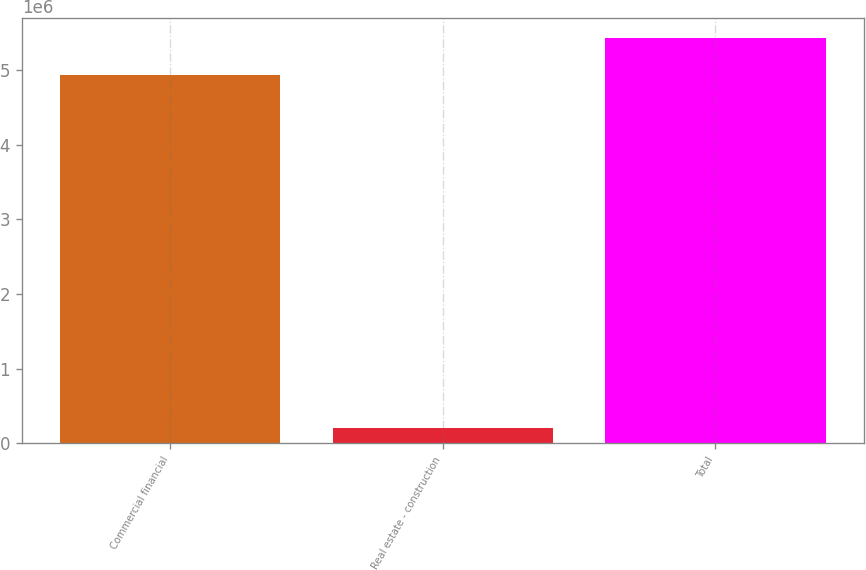Convert chart to OTSL. <chart><loc_0><loc_0><loc_500><loc_500><bar_chart><fcel>Commercial financial<fcel>Real estate - construction<fcel>Total<nl><fcel>4.93513e+06<fcel>203576<fcel>5.42864e+06<nl></chart> 